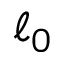Convert formula to latex. <formula><loc_0><loc_0><loc_500><loc_500>\ell _ { 0 }</formula> 